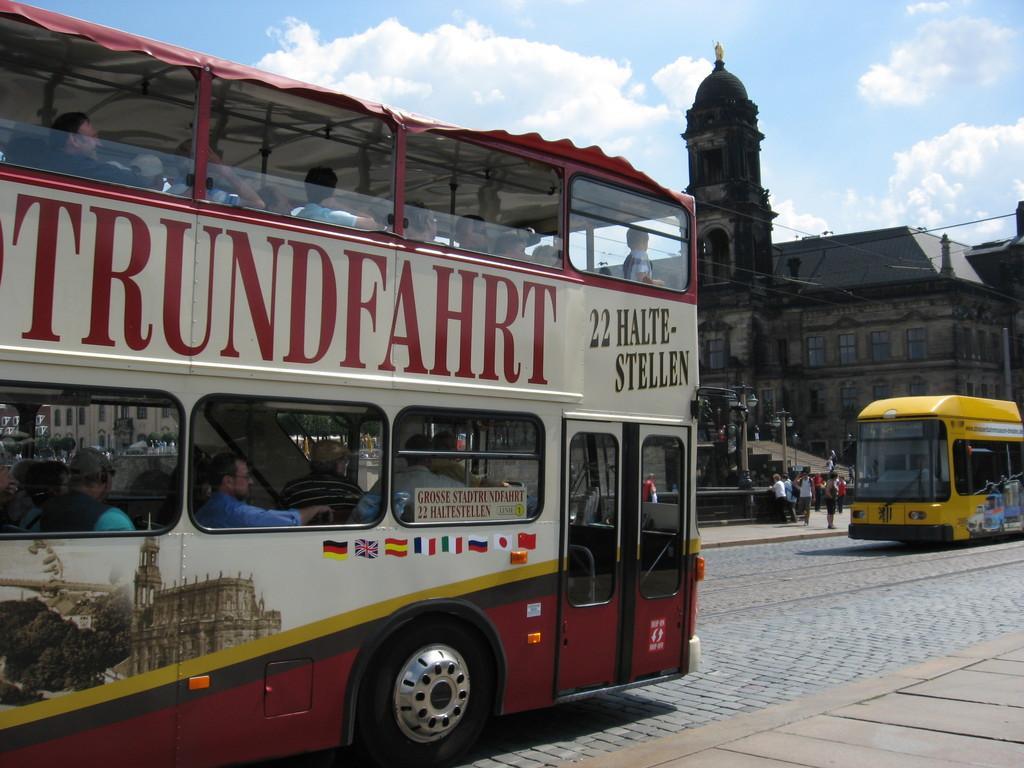Please provide a concise description of this image. In this image there is the sky towards the top of the image, there are clouds in the sky, there is a building towards the right of the image, there are windows, there are group of persons standing, there is a bus towards the right of the image, there is a bus towards the left of the image, there are persons sitting in the bus, there is text and number on the bus. 